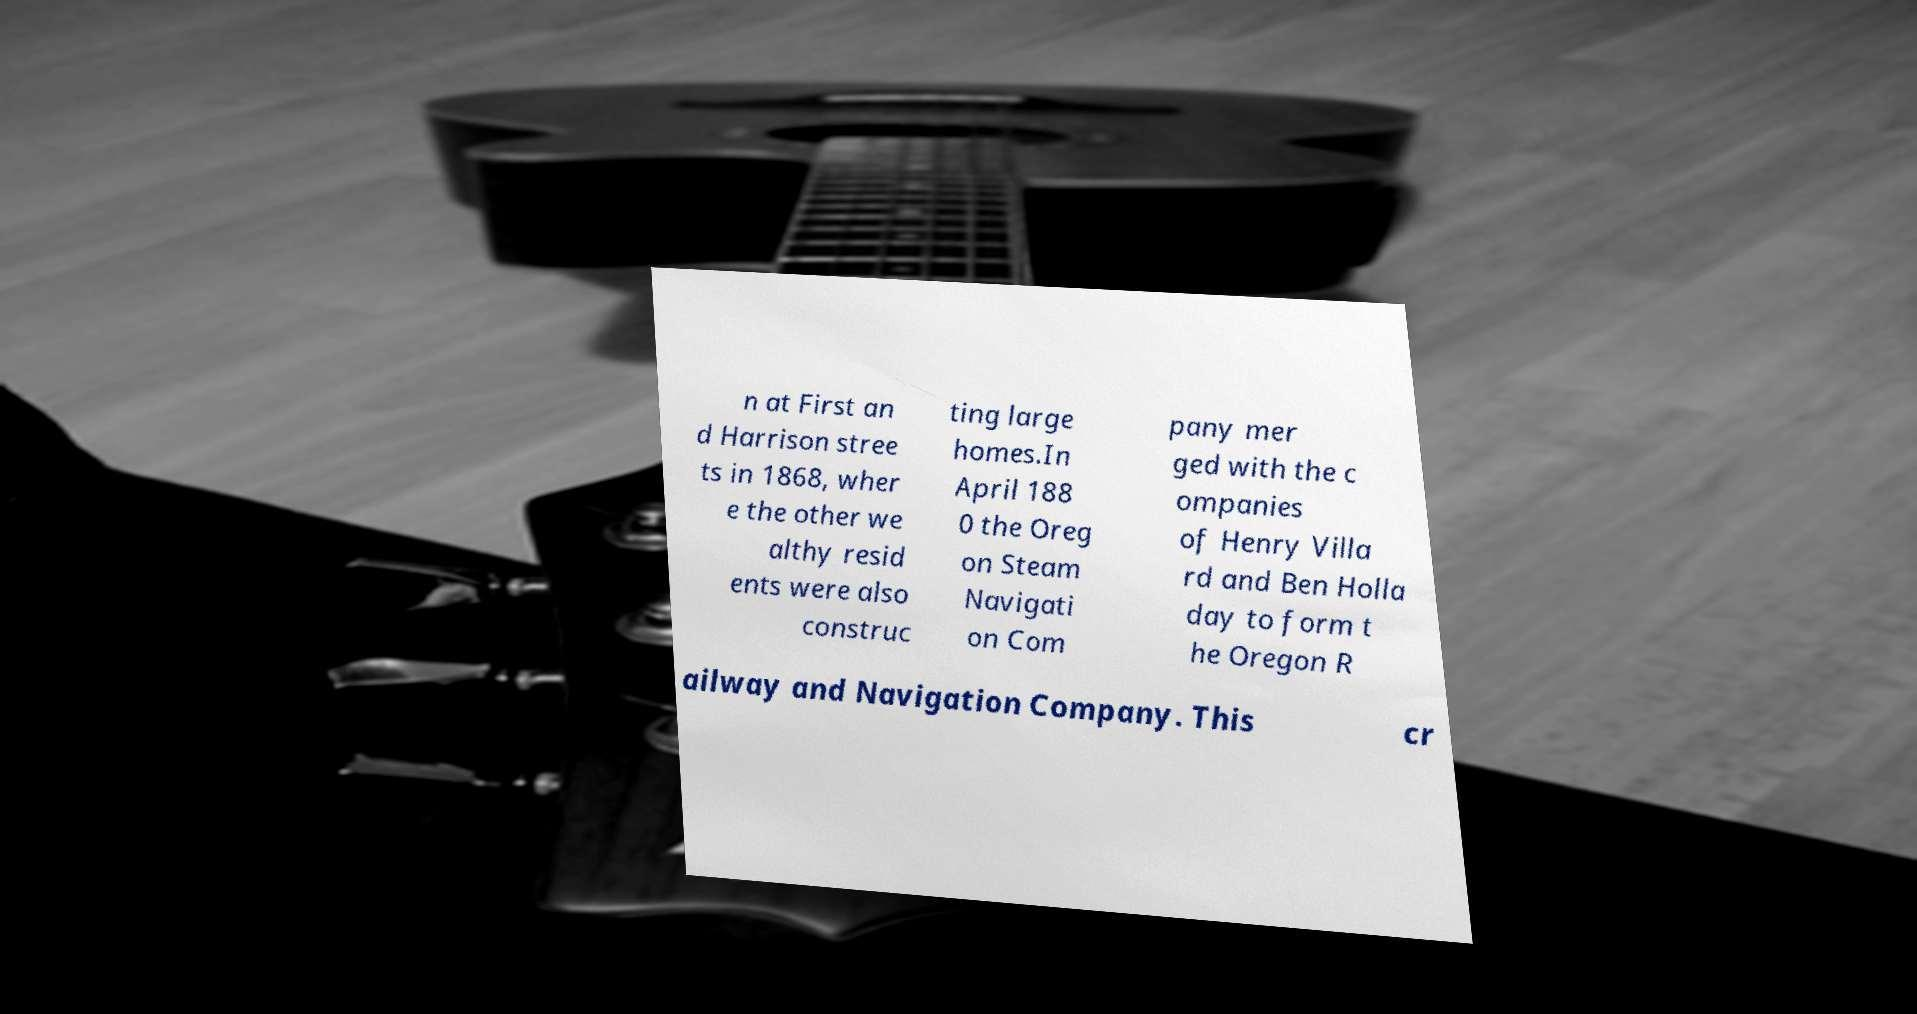Please identify and transcribe the text found in this image. n at First an d Harrison stree ts in 1868, wher e the other we althy resid ents were also construc ting large homes.In April 188 0 the Oreg on Steam Navigati on Com pany mer ged with the c ompanies of Henry Villa rd and Ben Holla day to form t he Oregon R ailway and Navigation Company. This cr 